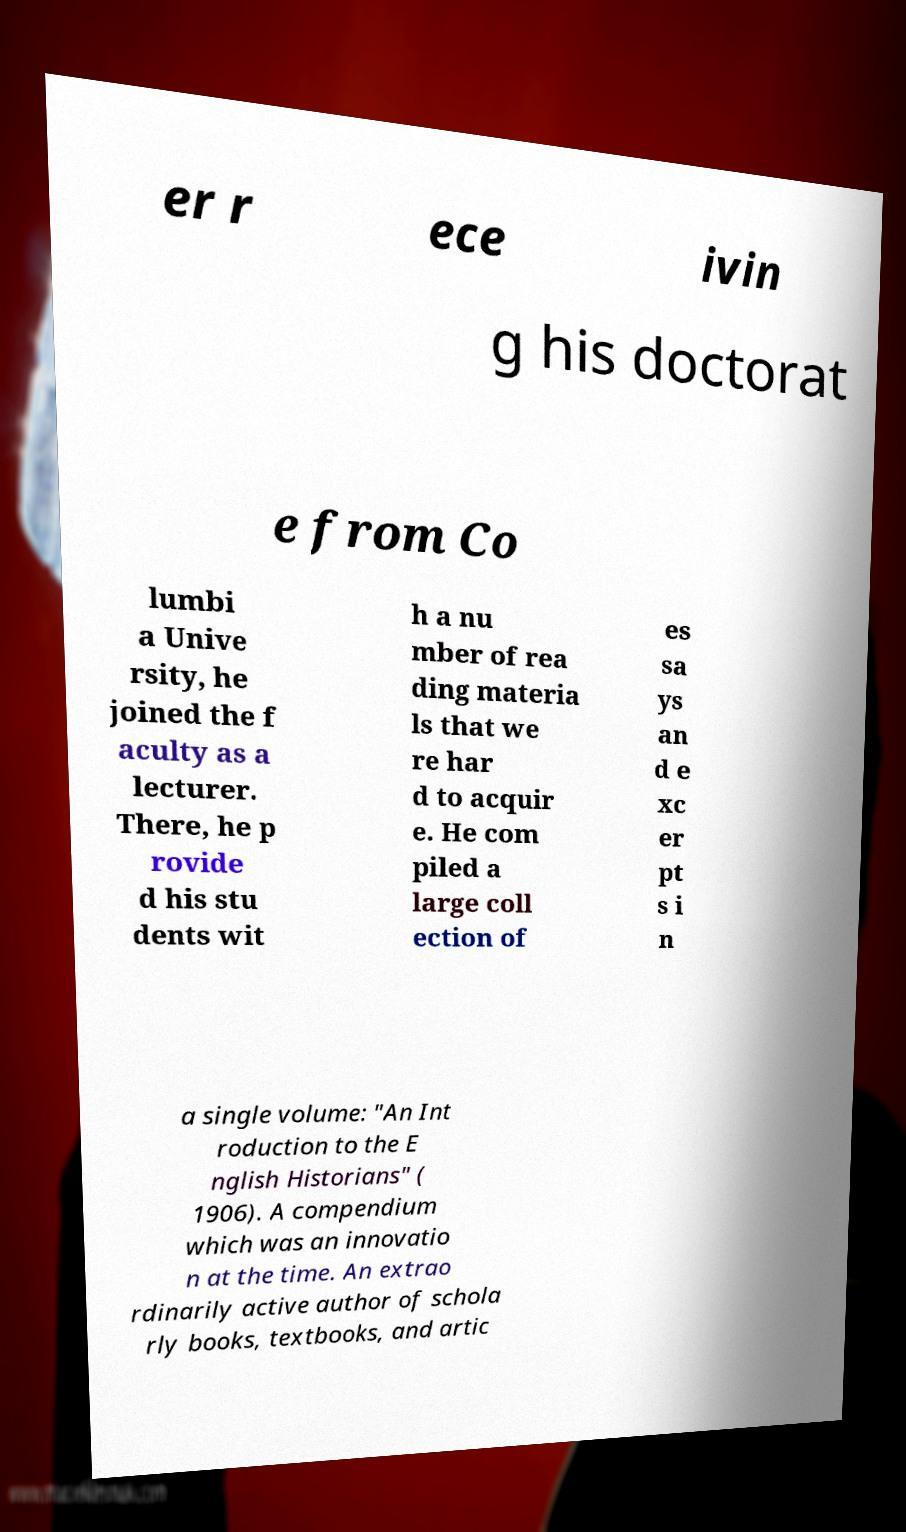Can you read and provide the text displayed in the image?This photo seems to have some interesting text. Can you extract and type it out for me? er r ece ivin g his doctorat e from Co lumbi a Unive rsity, he joined the f aculty as a lecturer. There, he p rovide d his stu dents wit h a nu mber of rea ding materia ls that we re har d to acquir e. He com piled a large coll ection of es sa ys an d e xc er pt s i n a single volume: "An Int roduction to the E nglish Historians" ( 1906). A compendium which was an innovatio n at the time. An extrao rdinarily active author of schola rly books, textbooks, and artic 